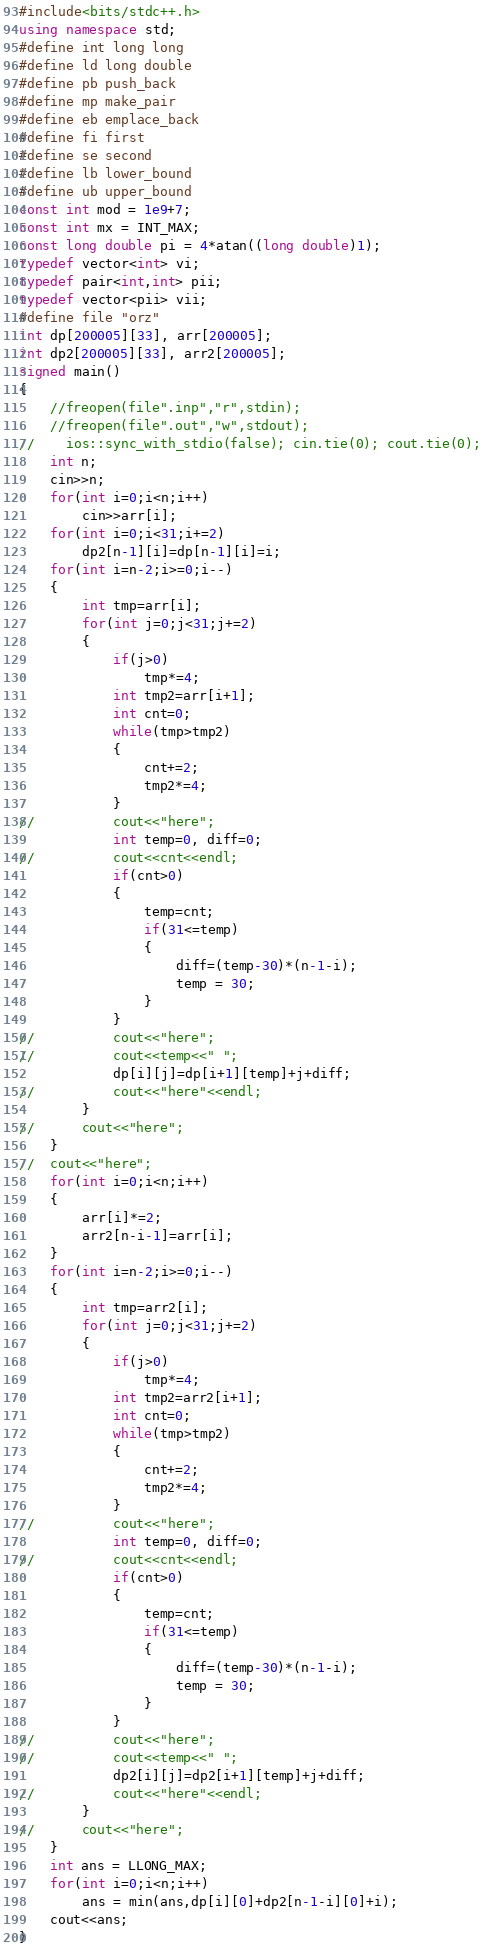Convert code to text. <code><loc_0><loc_0><loc_500><loc_500><_C++_>#include<bits/stdc++.h>
using namespace std;
#define int long long
#define ld long double
#define pb push_back
#define mp make_pair
#define eb emplace_back
#define fi first
#define se second
#define lb lower_bound
#define ub upper_bound
const int mod = 1e9+7;
const int mx = INT_MAX;
const long double pi = 4*atan((long double)1);
typedef vector<int> vi;
typedef pair<int,int> pii;
typedef vector<pii> vii;
#define file "orz"
int dp[200005][33], arr[200005];
int dp2[200005][33], arr2[200005];
signed main()
{
    //freopen(file".inp","r",stdin);
    //freopen(file".out","w",stdout);
//    ios::sync_with_stdio(false); cin.tie(0); cout.tie(0);
    int n;
    cin>>n;
    for(int i=0;i<n;i++)
    	cin>>arr[i]; 
    for(int i=0;i<31;i+=2)
  	 	dp2[n-1][i]=dp[n-1][i]=i;
    for(int i=n-2;i>=0;i--)
    {
    	int tmp=arr[i];
    	for(int j=0;j<31;j+=2)
    	{
    		if(j>0)
    			tmp*=4;
    		int tmp2=arr[i+1];
    		int cnt=0;
    		while(tmp>tmp2)
    		{
    			cnt+=2;
    			tmp2*=4;
			}
//			cout<<"here";
			int temp=0, diff=0;
//			cout<<cnt<<endl;
			if(cnt>0)
			{
				temp=cnt;
				if(31<=temp)
				{
					diff=(temp-30)*(n-1-i);
					temp = 30;
				}
			}
//			cout<<"here";
//			cout<<temp<<" ";
			dp[i][j]=dp[i+1][temp]+j+diff;
//			cout<<"here"<<endl;
		}
//		cout<<"here";
	}
//	cout<<"here";
	for(int i=0;i<n;i++)
	{
		arr[i]*=2;
		arr2[n-i-1]=arr[i];
	}
	for(int i=n-2;i>=0;i--)
    {
    	int tmp=arr2[i];
    	for(int j=0;j<31;j+=2)
    	{
    		if(j>0)
    			tmp*=4;
    		int tmp2=arr2[i+1];
    		int cnt=0;
    		while(tmp>tmp2)
    		{
    			cnt+=2;
    			tmp2*=4;
			}
//			cout<<"here";
			int temp=0, diff=0;
//			cout<<cnt<<endl;
			if(cnt>0)
			{
				temp=cnt;
				if(31<=temp)
				{
					diff=(temp-30)*(n-1-i);
					temp = 30;
				}
			}
//			cout<<"here";
//			cout<<temp<<" ";
			dp2[i][j]=dp2[i+1][temp]+j+diff;
//			cout<<"here"<<endl;
		}
//		cout<<"here";
	}
	int ans = LLONG_MAX;	
	for(int i=0;i<n;i++)
		ans = min(ans,dp[i][0]+dp2[n-1-i][0]+i);
	cout<<ans;
}
</code> 